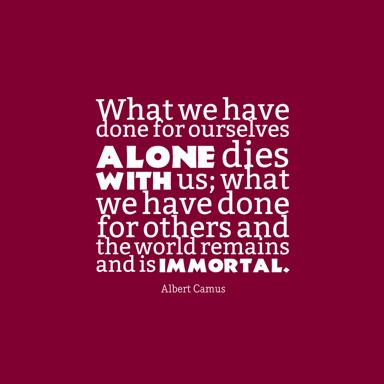How could the quote by Albert Camus be applied in a modern context? In today's world, where individual achievements are often celebrated, Camus' quote invites us to reflect on the broader impact of our actions. It can be applied to encourage societal and community-focused perspectives, advocating for actions that support sustainability, social justice, and community aid. This perspective pushes individuals to think about legacy and collective well-being rather than transient, personal success. 